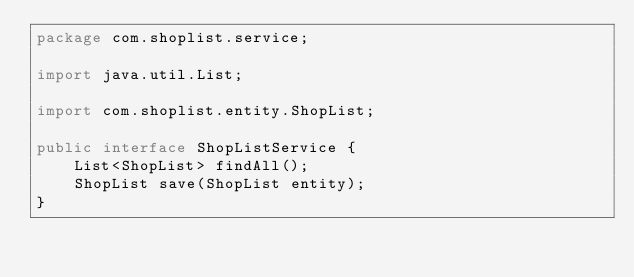<code> <loc_0><loc_0><loc_500><loc_500><_Java_>package com.shoplist.service;

import java.util.List;

import com.shoplist.entity.ShopList;

public interface ShopListService {
	List<ShopList> findAll();
	ShopList save(ShopList entity);
}
</code> 